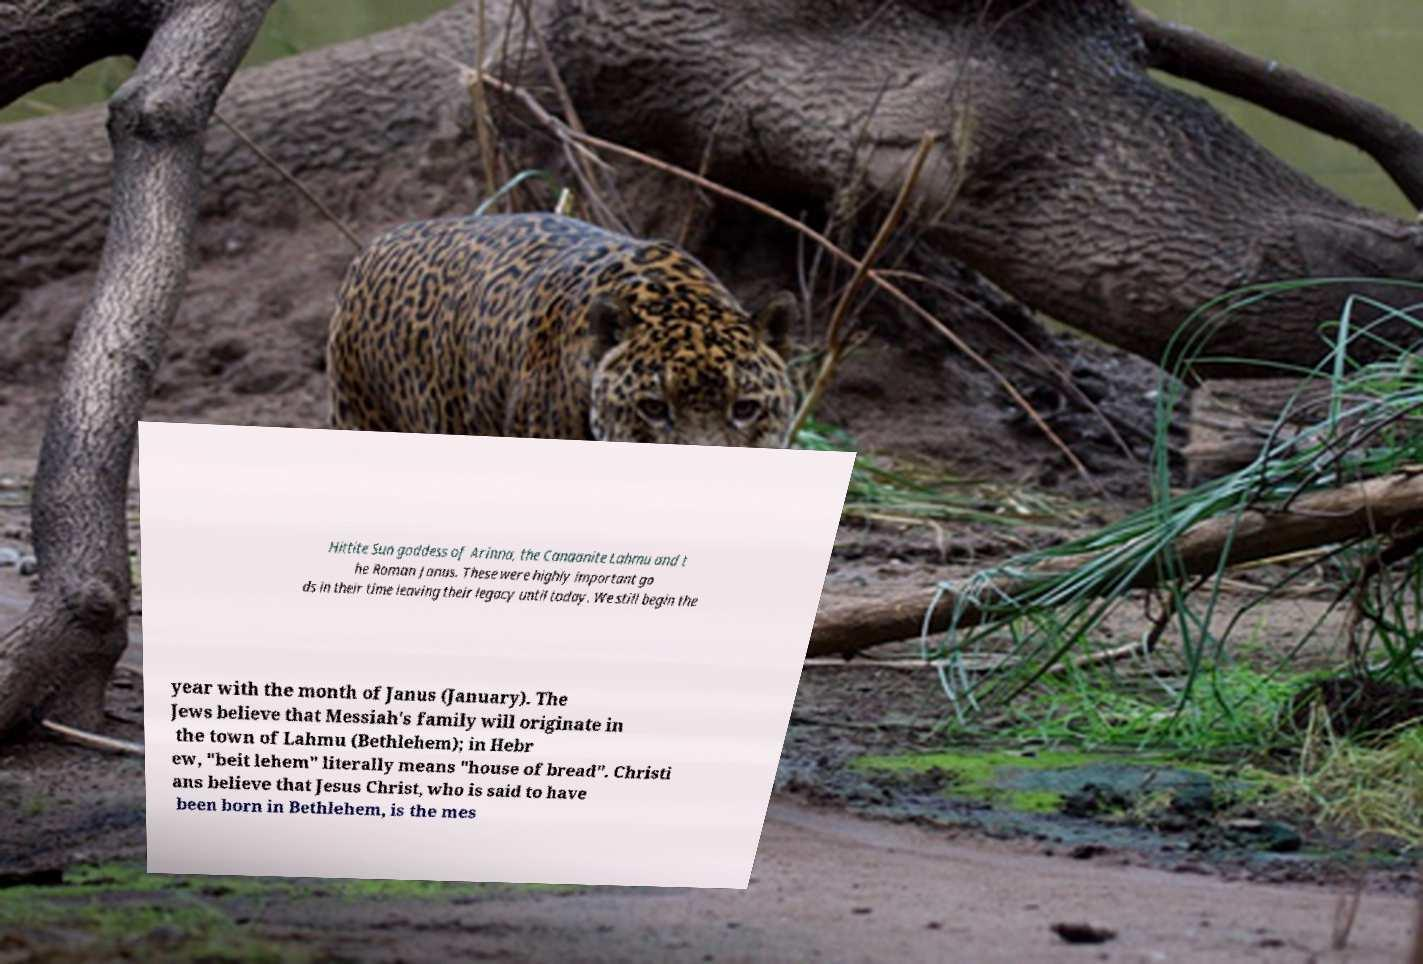Can you read and provide the text displayed in the image?This photo seems to have some interesting text. Can you extract and type it out for me? Hittite Sun goddess of Arinna, the Canaanite Lahmu and t he Roman Janus. These were highly important go ds in their time leaving their legacy until today. We still begin the year with the month of Janus (January). The Jews believe that Messiah's family will originate in the town of Lahmu (Bethlehem); in Hebr ew, "beit lehem" literally means "house of bread". Christi ans believe that Jesus Christ, who is said to have been born in Bethlehem, is the mes 